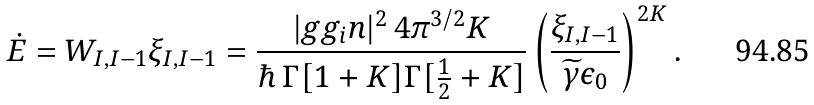Convert formula to latex. <formula><loc_0><loc_0><loc_500><loc_500>\dot { E } = W _ { I , I - 1 } \xi _ { I , I - 1 } = \frac { | g g _ { i } n | ^ { 2 } \, 4 \pi ^ { 3 / 2 } K } { \hbar { \, } \Gamma [ 1 + K ] \Gamma [ \frac { 1 } { 2 } + K ] } \left ( \frac { \xi _ { I , I - 1 } } { \widetilde { \gamma } \epsilon _ { 0 } } \right ) ^ { 2 K } .</formula> 